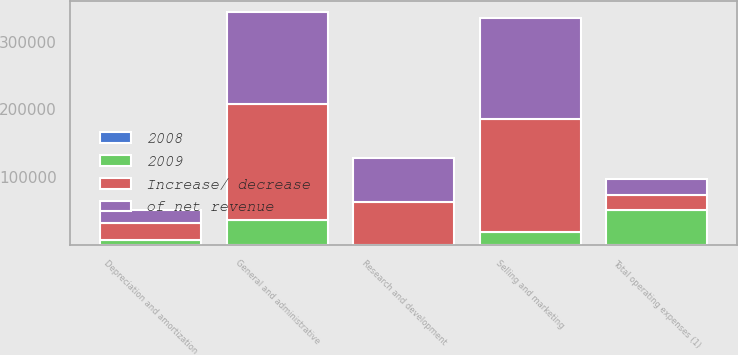Convert chart. <chart><loc_0><loc_0><loc_500><loc_500><stacked_bar_chart><ecel><fcel>Selling and marketing<fcel>General and administrative<fcel>Research and development<fcel>Depreciation and amortization<fcel>Total operating expenses (1)<nl><fcel>of net revenue<fcel>148624<fcel>135127<fcel>63748<fcel>18623<fcel>22255.5<nl><fcel>2008<fcel>15.3<fcel>14<fcel>6.6<fcel>1.9<fcel>39.3<nl><fcel>Increase/ decrease<fcel>167380<fcel>171440<fcel>63929<fcel>25755<fcel>22255.5<nl><fcel>2009<fcel>18756<fcel>36313<fcel>181<fcel>7132<fcel>52106<nl></chart> 